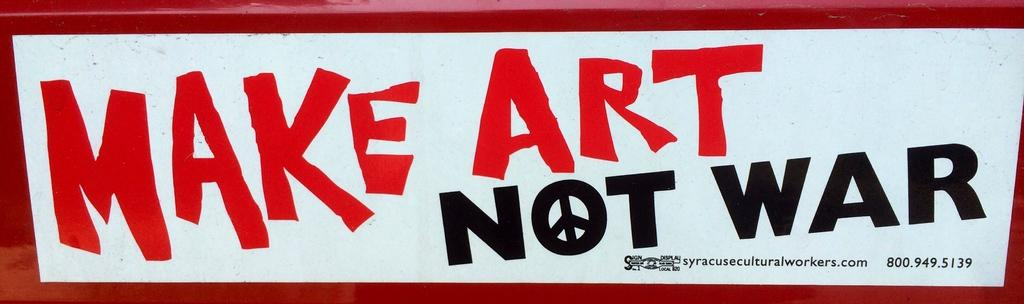<image>
Create a compact narrative representing the image presented. A poster that reads make art not war. 